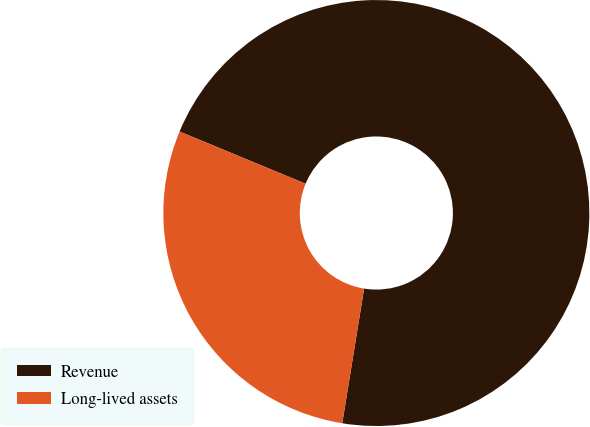Convert chart to OTSL. <chart><loc_0><loc_0><loc_500><loc_500><pie_chart><fcel>Revenue<fcel>Long-lived assets<nl><fcel>71.31%<fcel>28.69%<nl></chart> 